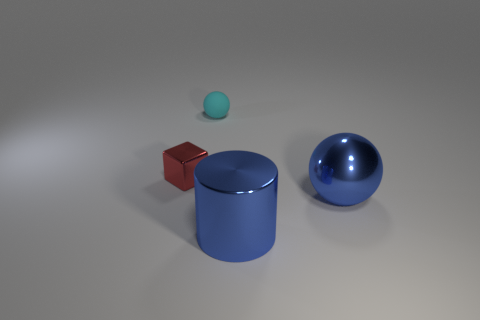Subtract 1 spheres. How many spheres are left? 1 Add 1 green rubber objects. How many objects exist? 5 Subtract 0 green balls. How many objects are left? 4 Subtract all yellow cylinders. Subtract all green cubes. How many cylinders are left? 1 Subtract all blue blocks. How many brown balls are left? 0 Subtract all blue balls. Subtract all small rubber things. How many objects are left? 2 Add 2 large metallic cylinders. How many large metallic cylinders are left? 3 Add 3 large gray things. How many large gray things exist? 3 